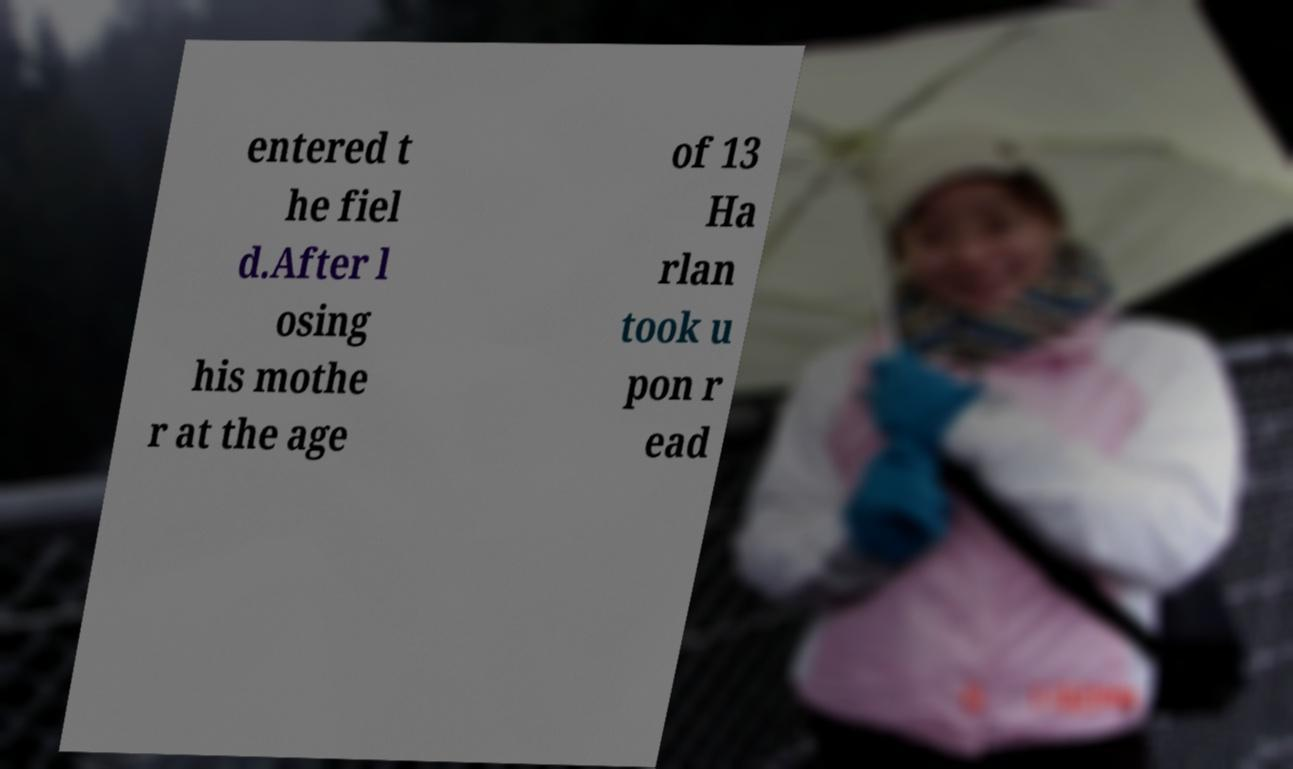Could you extract and type out the text from this image? entered t he fiel d.After l osing his mothe r at the age of 13 Ha rlan took u pon r ead 